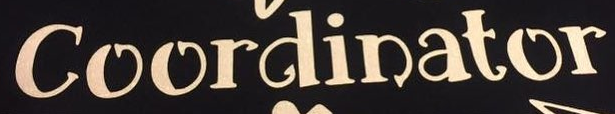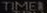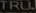What words can you see in these images in sequence, separated by a semicolon? Coordinator; TIMEI; TRU 